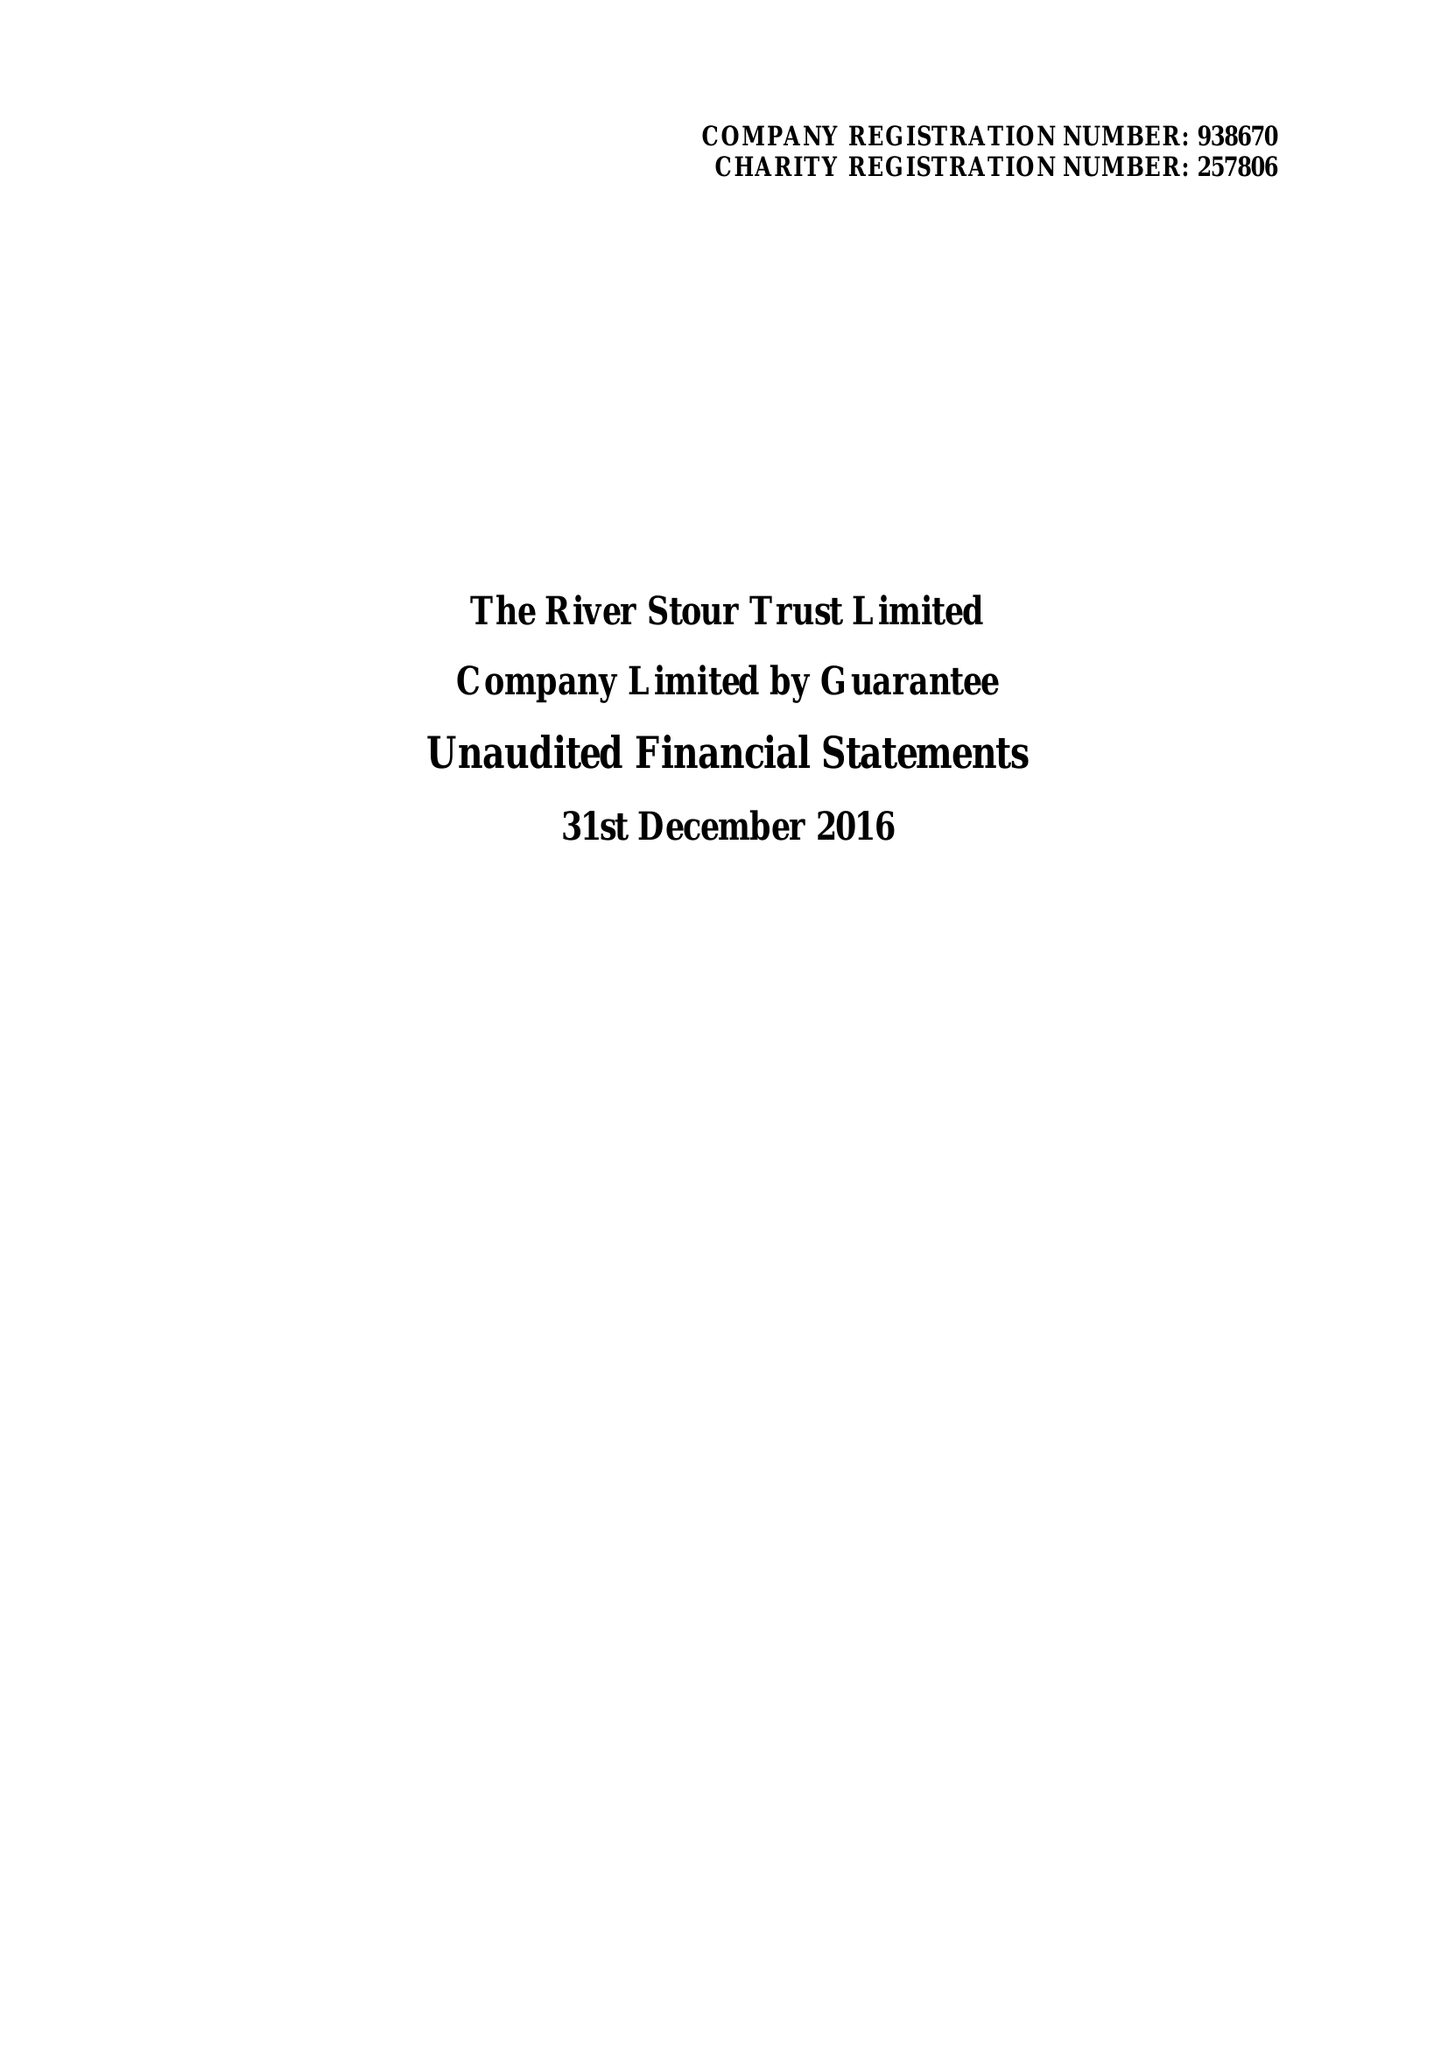What is the value for the spending_annually_in_british_pounds?
Answer the question using a single word or phrase. 98930.00 